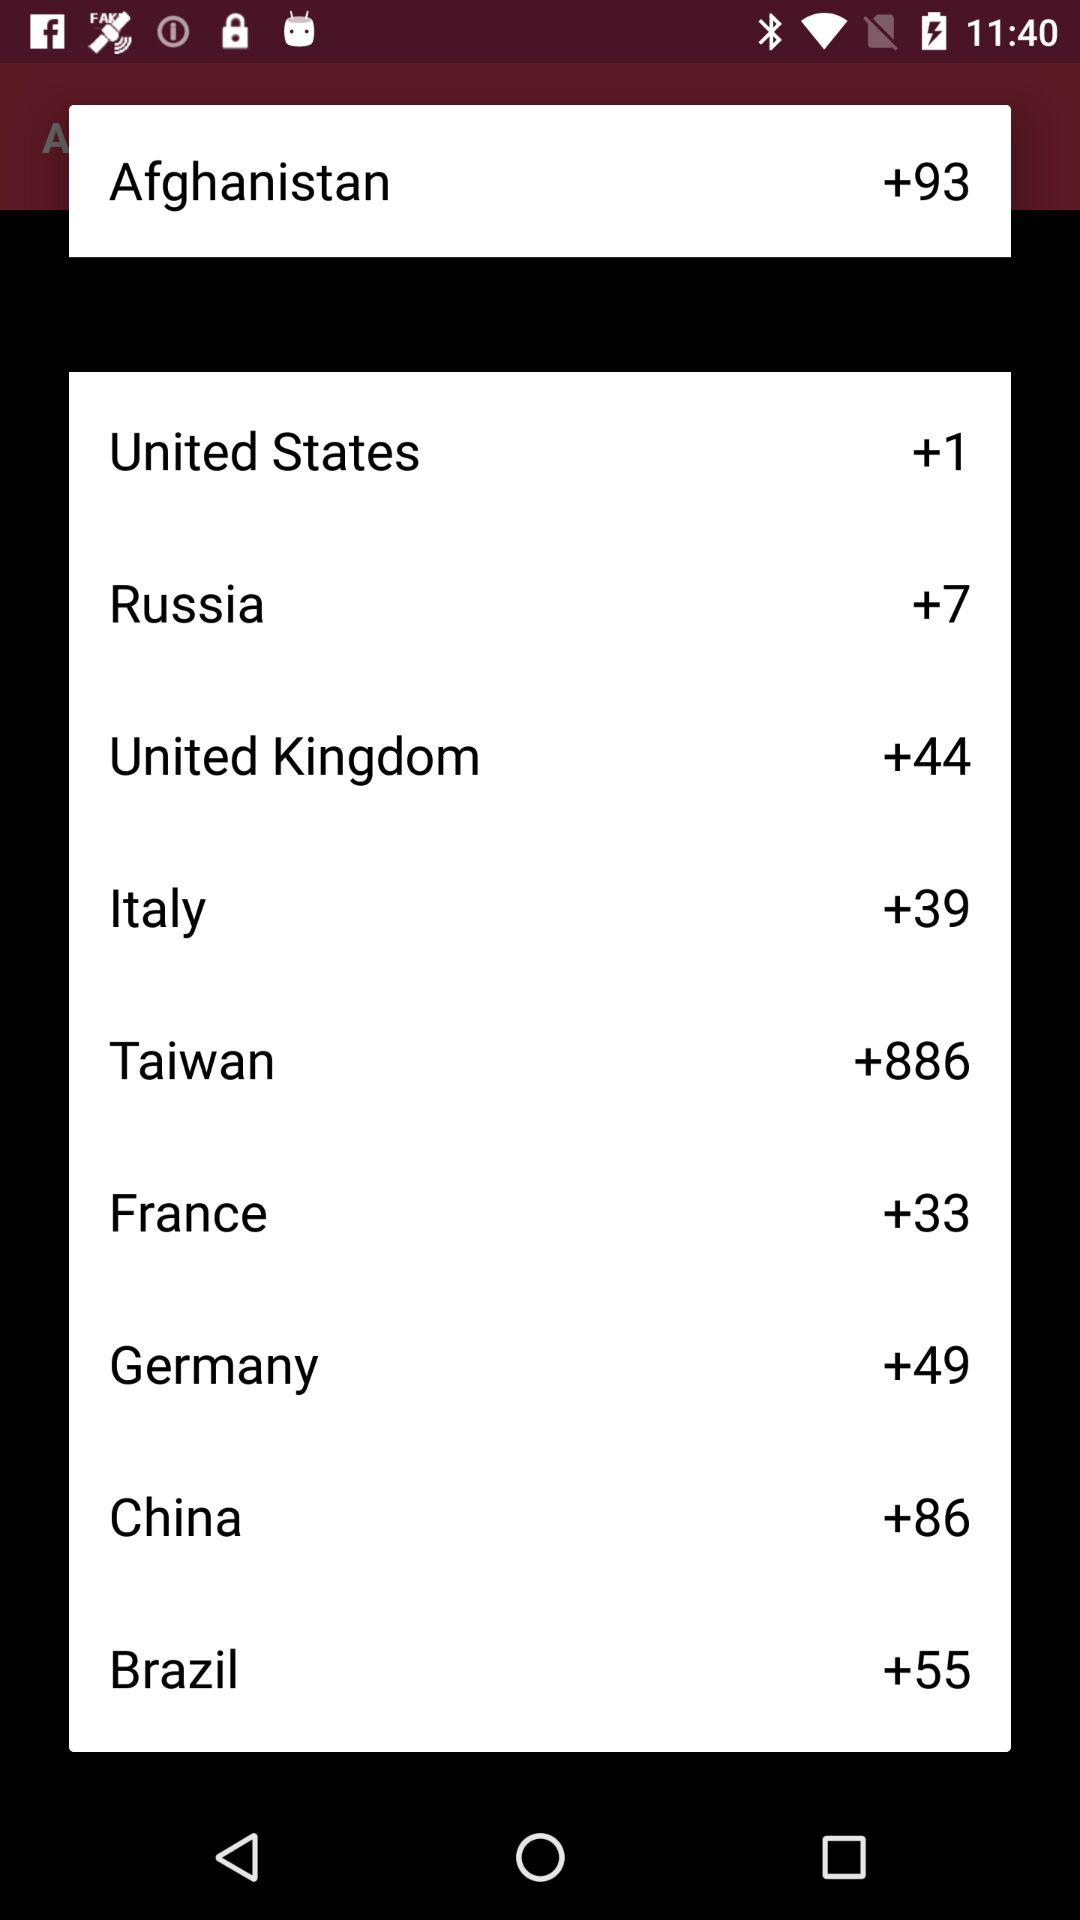What is the country code for Afghanistan? The country code for Afghanistan is +93. 